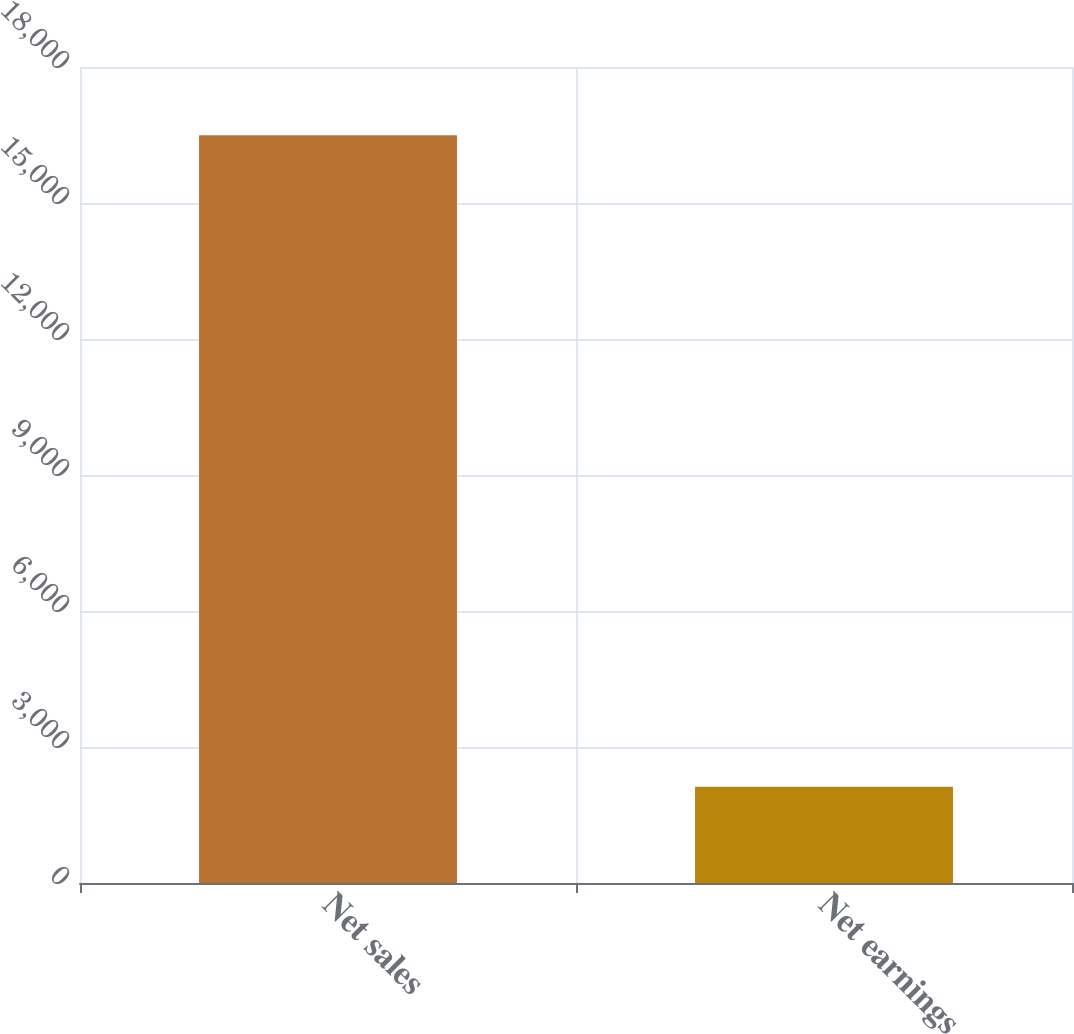<chart> <loc_0><loc_0><loc_500><loc_500><bar_chart><fcel>Net sales<fcel>Net earnings<nl><fcel>16493<fcel>2123<nl></chart> 